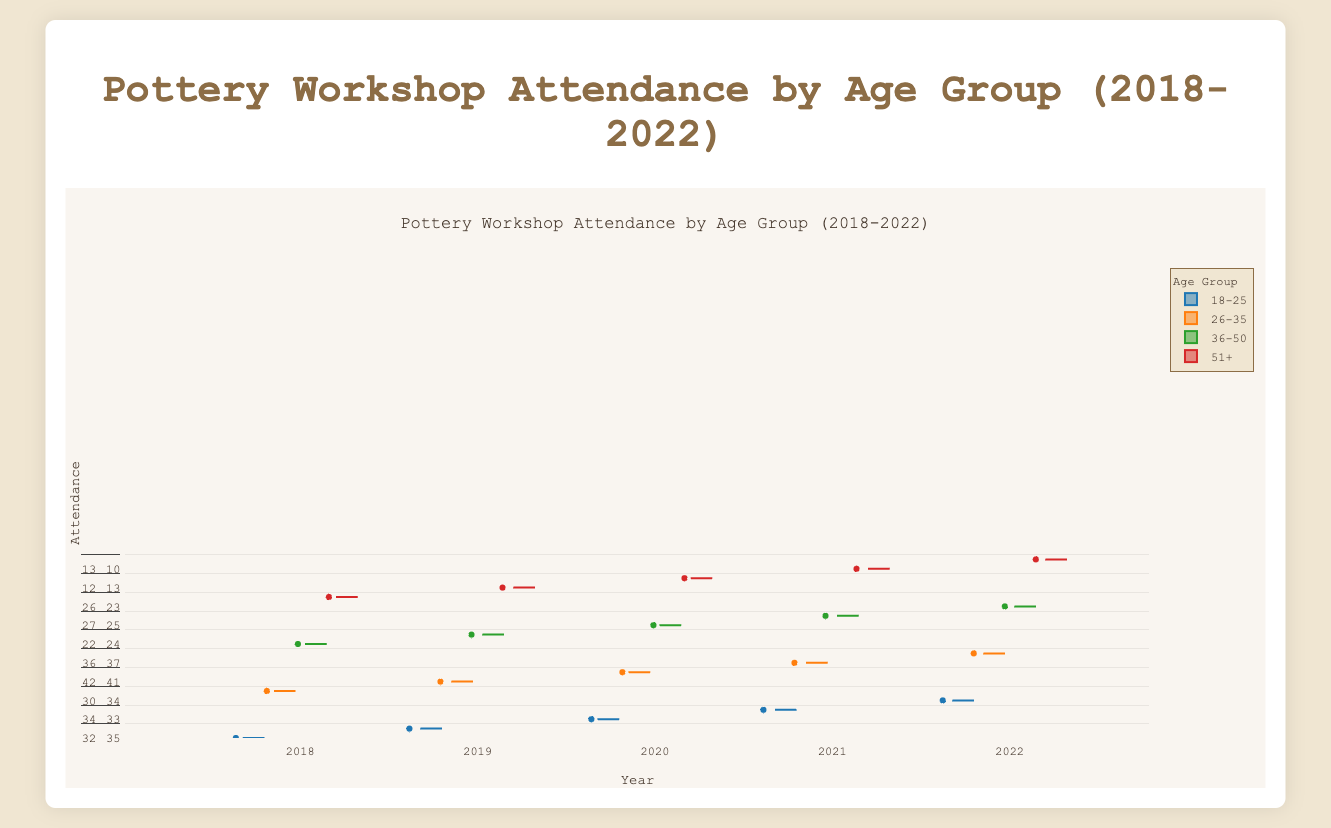What is the title of the figure? The title of the figure is displayed at the top and is clearly written as "Pottery Workshop Attendance by Age Group (2018-2022)".
Answer: Pottery Workshop Attendance by Age Group (2018-2022) Which age group has the highest median attendance in 2018? By looking at the box for each age group for the year 2018, the median is represented by the line inside the box. The age group 26-35 has the highest median attendance.
Answer: 26-35 How did the median attendance of the 18-25 age group change from 2018 to 2022? To find the change, first identify the median value of the 18-25 age group in both 2018 and 2022. In 2018, the median is around 31, and in 2022, it is around 34. The median attendance increased by 3.
Answer: Increased by 3 Which year had the lowest median attendance for the age group 51+? By examining the box plots for the age group 51+ across all years, the year 2020 shows the lowest median attendance.
Answer: 2020 What is the range of attendance for the age group 36-50 in 2022? The range of attendance is the difference between the maximum and minimum values in the box plot. For the age group 36-50 in 2022, the maximum is around 28 and the minimum is around 21, so the range is 7.
Answer: 7 Compare the interquartile range (IQR) of the age groups 18-25 and 51+ in 2021. Which one is larger? IQR is the difference between the 75th percentile and the 25th percentile. For 18-25 in 2021, it's between 38 (75th) and 32 (25th), giving an IQR of 6. For 51+ in 2021, it's between 15 (75th) and 11 (25th), giving an IQR of 4. The 18-25 age group has a larger IQR.
Answer: 18-25 Which age group had the most fluctuating attendance in 2022? The most fluctuating attendance can be visualized by the length of the whiskers in the box plot. The age group 26-35 shows the longest whiskers in 2022, indicating the most fluctuation.
Answer: 26-35 Was there an overall upward trend in attendance for the age group 26-35 from 2018 to 2022? To determine an upward trend, compare the median values over the years. For 26-35, the medians for 2018, 2019, 2020, 2021, and 2022 are increasing starting from 38, 39, 33, 39, and finally 42. This indicates an overall upward trend.
Answer: Yes Identify the age group with the smallest change in median attendance from 2018 to 2022. Check the median values for each age group in 2018 and 2022. The age group 51+ has medians of around 12 in both years, showing the smallest change.
Answer: 51+ Which age group had a median attendance of 36 in 2021? By inspecting the medians of the age groups in the year 2021, the age group 26-35 has a median attendance of 36.
Answer: 26-35 